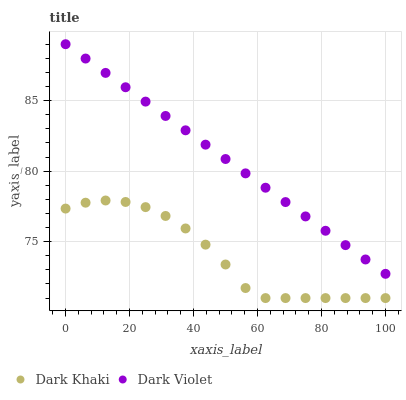Does Dark Khaki have the minimum area under the curve?
Answer yes or no. Yes. Does Dark Violet have the maximum area under the curve?
Answer yes or no. Yes. Does Dark Violet have the minimum area under the curve?
Answer yes or no. No. Is Dark Violet the smoothest?
Answer yes or no. Yes. Is Dark Khaki the roughest?
Answer yes or no. Yes. Is Dark Violet the roughest?
Answer yes or no. No. Does Dark Khaki have the lowest value?
Answer yes or no. Yes. Does Dark Violet have the lowest value?
Answer yes or no. No. Does Dark Violet have the highest value?
Answer yes or no. Yes. Is Dark Khaki less than Dark Violet?
Answer yes or no. Yes. Is Dark Violet greater than Dark Khaki?
Answer yes or no. Yes. Does Dark Khaki intersect Dark Violet?
Answer yes or no. No. 